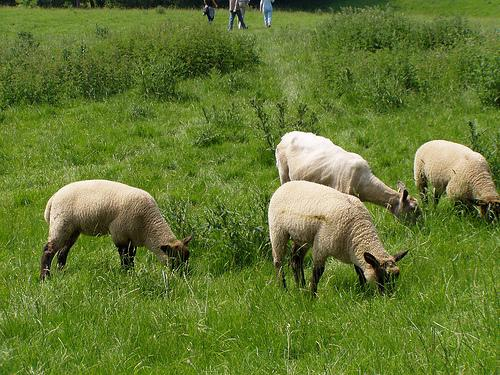Question: what color is the field and grass?
Choices:
A. Brown.
B. Black.
C. Green.
D. Red.
Answer with the letter. Answer: C Question: how many animals are visible?
Choices:
A. Two.
B. Three.
C. Five.
D. Four.
Answer with the letter. Answer: D Question: why are the animals heads down?
Choices:
A. Eating.
B. They are eating grass.
C. Smelling the ground.
D. For food.
Answer with the letter. Answer: B Question: what are the sheep eating?
Choices:
A. Wheat.
B. A carrot.
C. Grass.
D. Hay.
Answer with the letter. Answer: C 